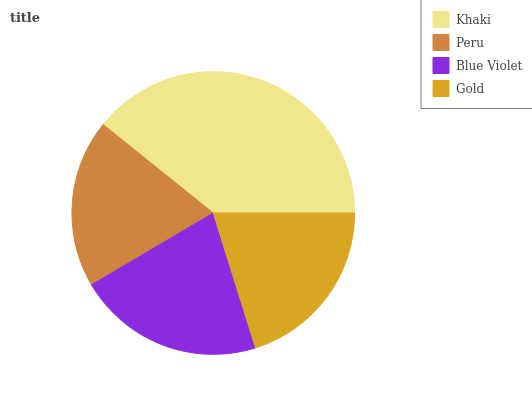Is Peru the minimum?
Answer yes or no. Yes. Is Khaki the maximum?
Answer yes or no. Yes. Is Blue Violet the minimum?
Answer yes or no. No. Is Blue Violet the maximum?
Answer yes or no. No. Is Blue Violet greater than Peru?
Answer yes or no. Yes. Is Peru less than Blue Violet?
Answer yes or no. Yes. Is Peru greater than Blue Violet?
Answer yes or no. No. Is Blue Violet less than Peru?
Answer yes or no. No. Is Blue Violet the high median?
Answer yes or no. Yes. Is Gold the low median?
Answer yes or no. Yes. Is Peru the high median?
Answer yes or no. No. Is Peru the low median?
Answer yes or no. No. 